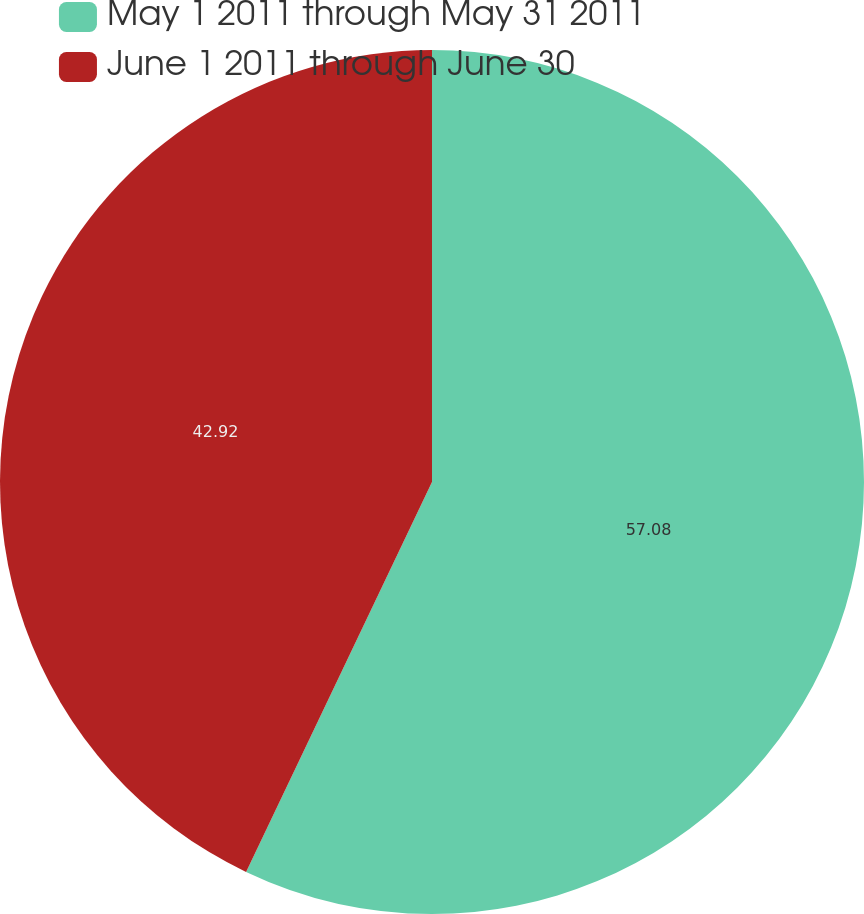Convert chart. <chart><loc_0><loc_0><loc_500><loc_500><pie_chart><fcel>May 1 2011 through May 31 2011<fcel>June 1 2011 through June 30<nl><fcel>57.08%<fcel>42.92%<nl></chart> 